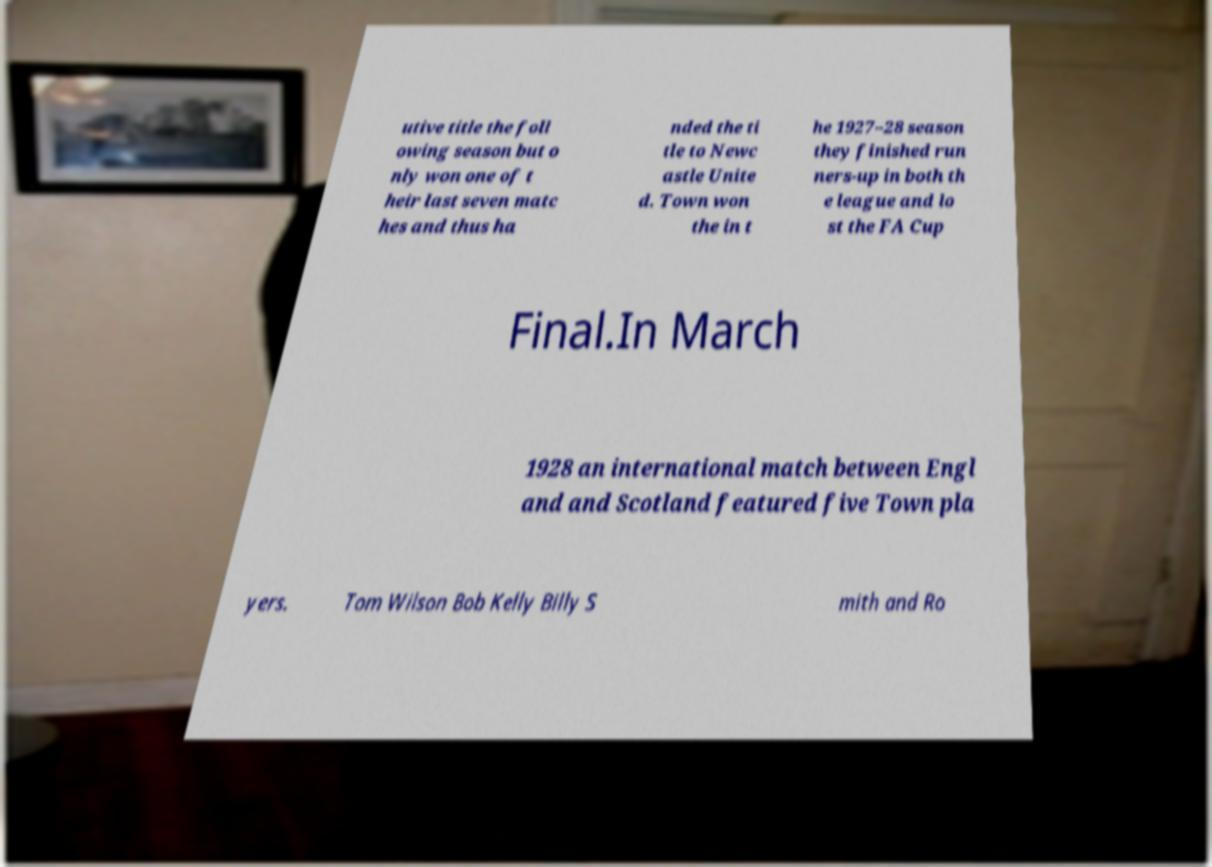What messages or text are displayed in this image? I need them in a readable, typed format. utive title the foll owing season but o nly won one of t heir last seven matc hes and thus ha nded the ti tle to Newc astle Unite d. Town won the in t he 1927–28 season they finished run ners-up in both th e league and lo st the FA Cup Final.In March 1928 an international match between Engl and and Scotland featured five Town pla yers. Tom Wilson Bob Kelly Billy S mith and Ro 